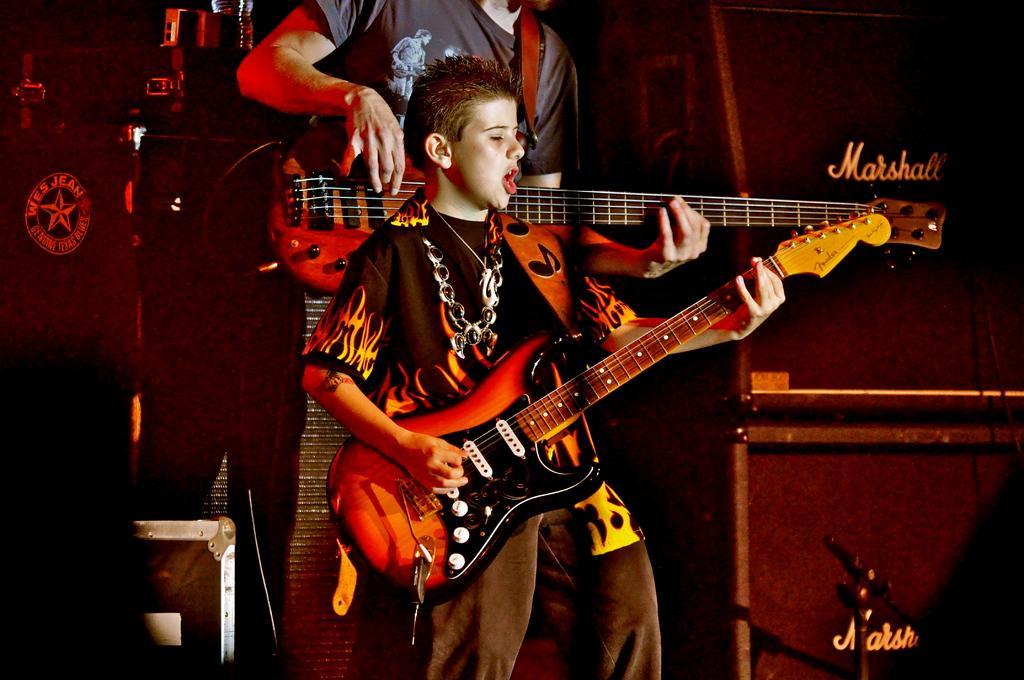Describe this image in one or two sentences. In this image we can see a man and a boy is holding guitar. Man is wearing grey color t-shirt and the boy is wearing black color t-shirt with jeans. Right side of the image black color boxes are there and one stand is present. 